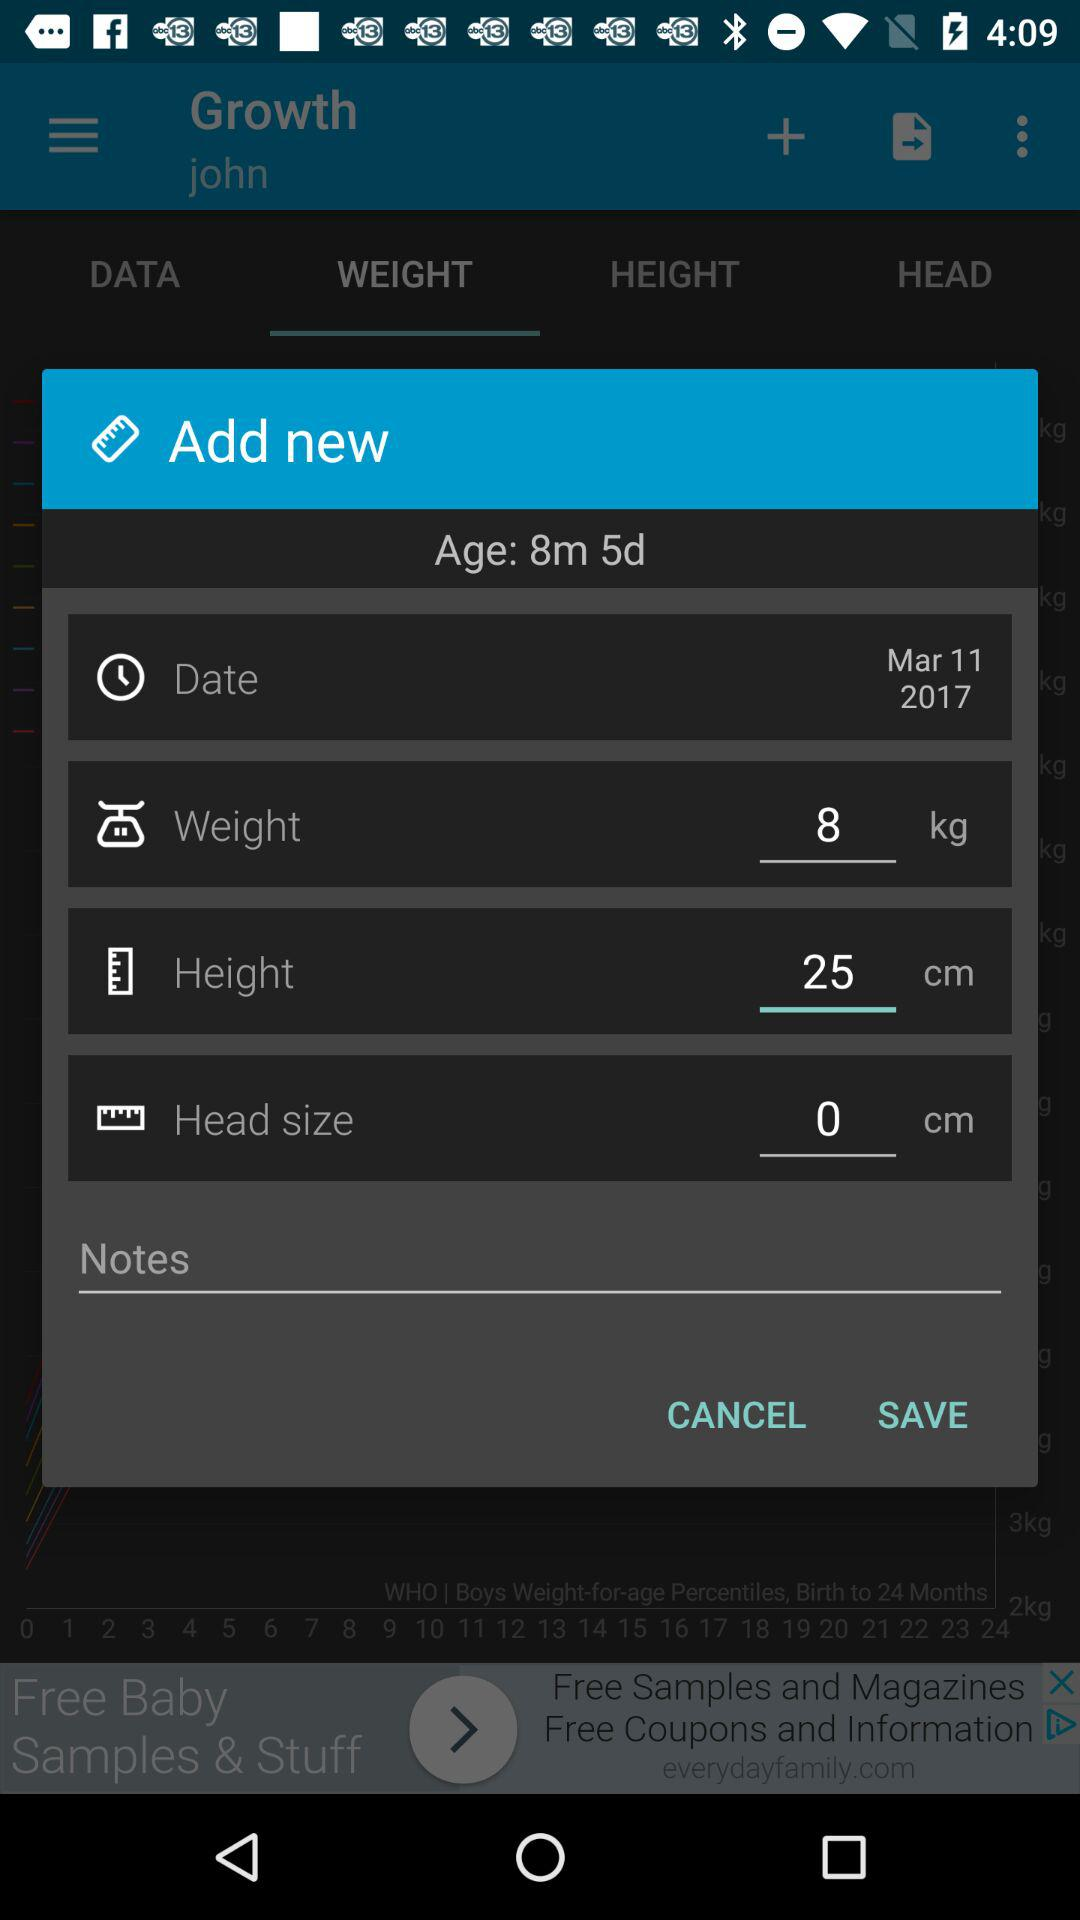In what option is 8 kg selected? The 8 kg is selected in the "Weight" option. 